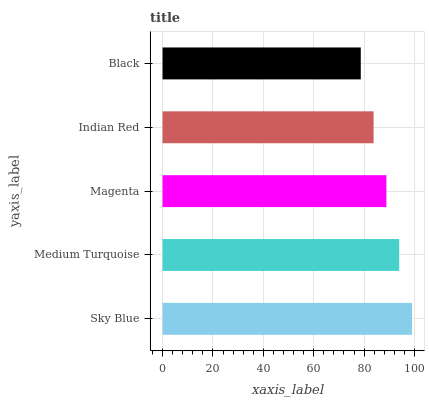Is Black the minimum?
Answer yes or no. Yes. Is Sky Blue the maximum?
Answer yes or no. Yes. Is Medium Turquoise the minimum?
Answer yes or no. No. Is Medium Turquoise the maximum?
Answer yes or no. No. Is Sky Blue greater than Medium Turquoise?
Answer yes or no. Yes. Is Medium Turquoise less than Sky Blue?
Answer yes or no. Yes. Is Medium Turquoise greater than Sky Blue?
Answer yes or no. No. Is Sky Blue less than Medium Turquoise?
Answer yes or no. No. Is Magenta the high median?
Answer yes or no. Yes. Is Magenta the low median?
Answer yes or no. Yes. Is Medium Turquoise the high median?
Answer yes or no. No. Is Medium Turquoise the low median?
Answer yes or no. No. 